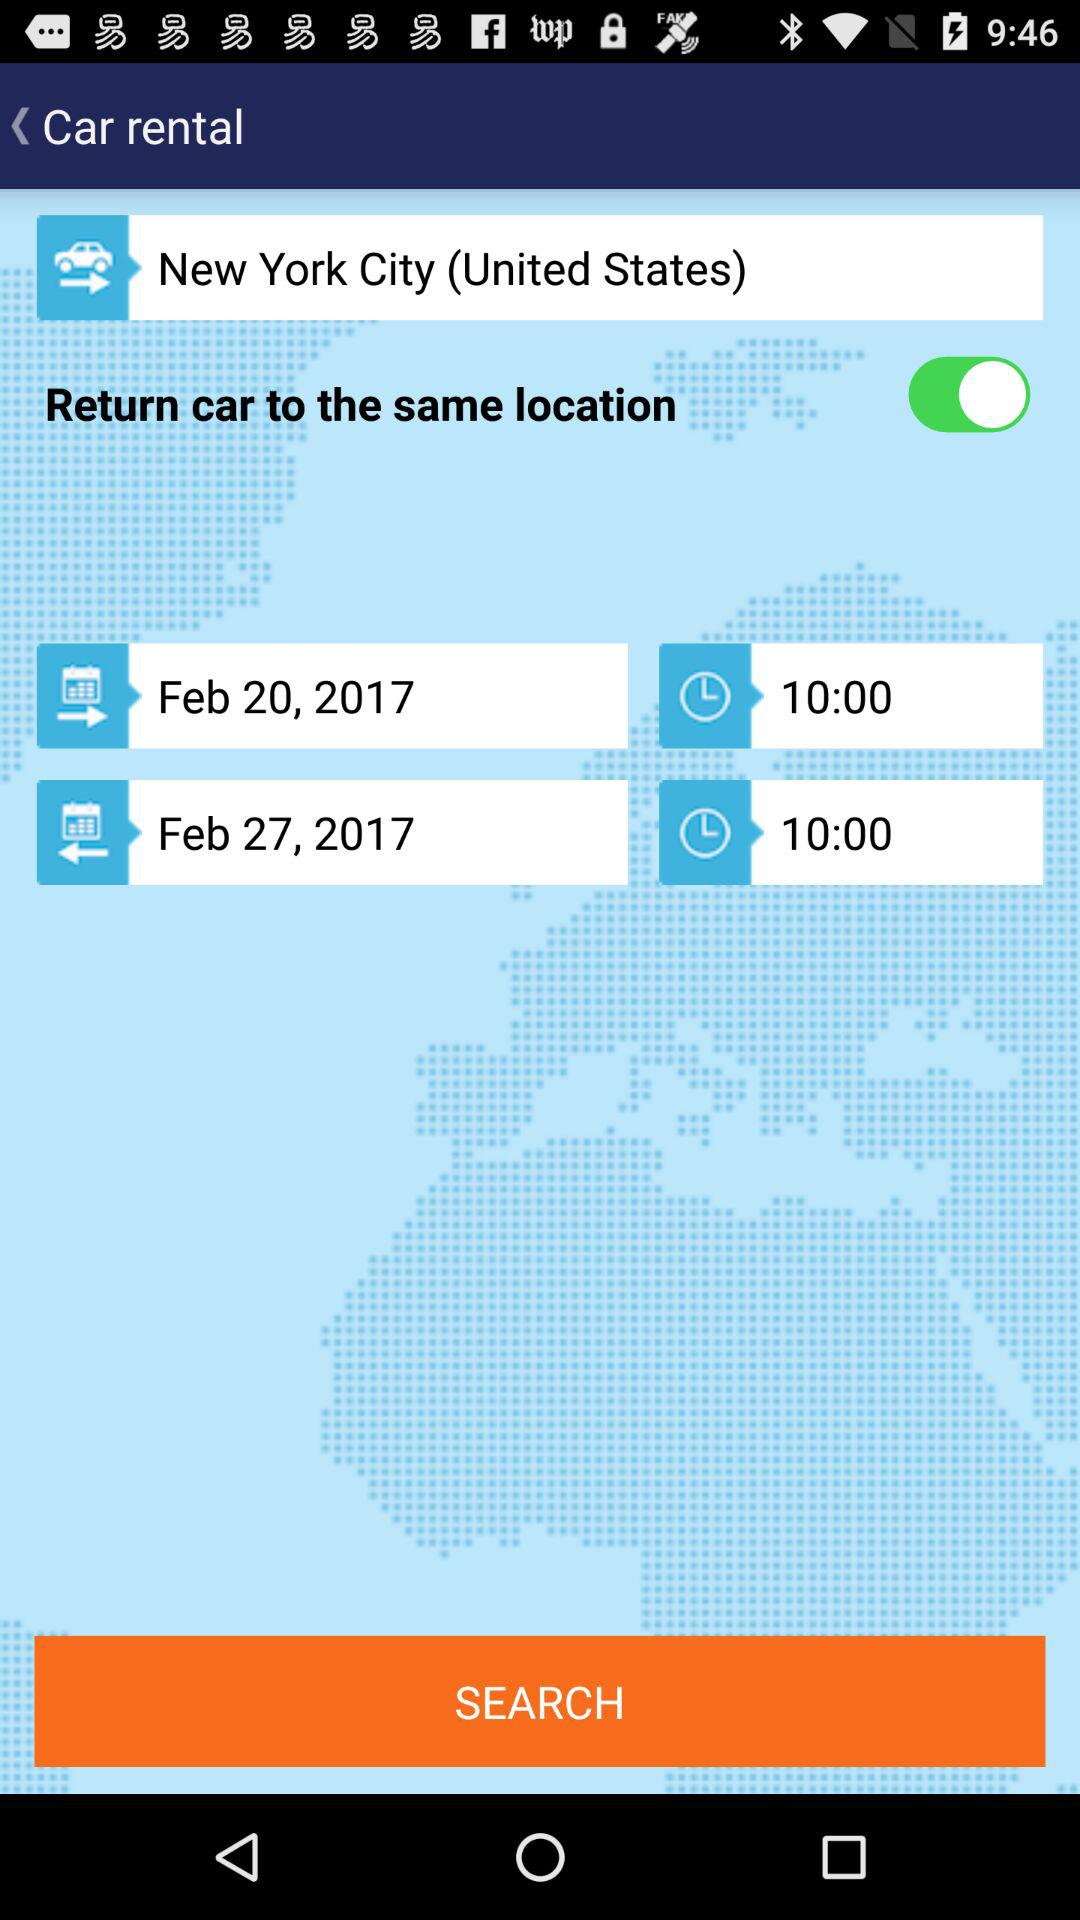Which city is mentioned? The mentioned city is New York City. 